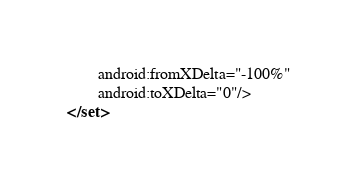Convert code to text. <code><loc_0><loc_0><loc_500><loc_500><_XML_>        android:fromXDelta="-100%"
        android:toXDelta="0"/>
</set></code> 